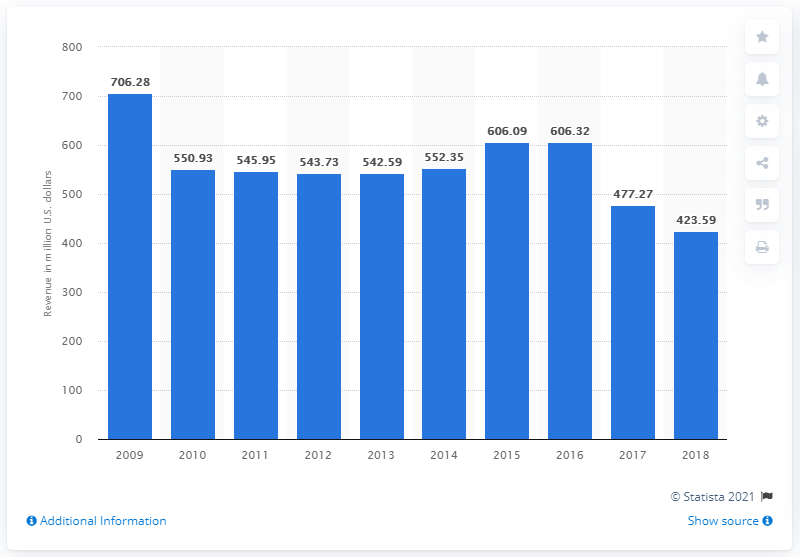List a handful of essential elements in this visual. Sonic Corporation generated $423.59 million in revenue in 2018. 